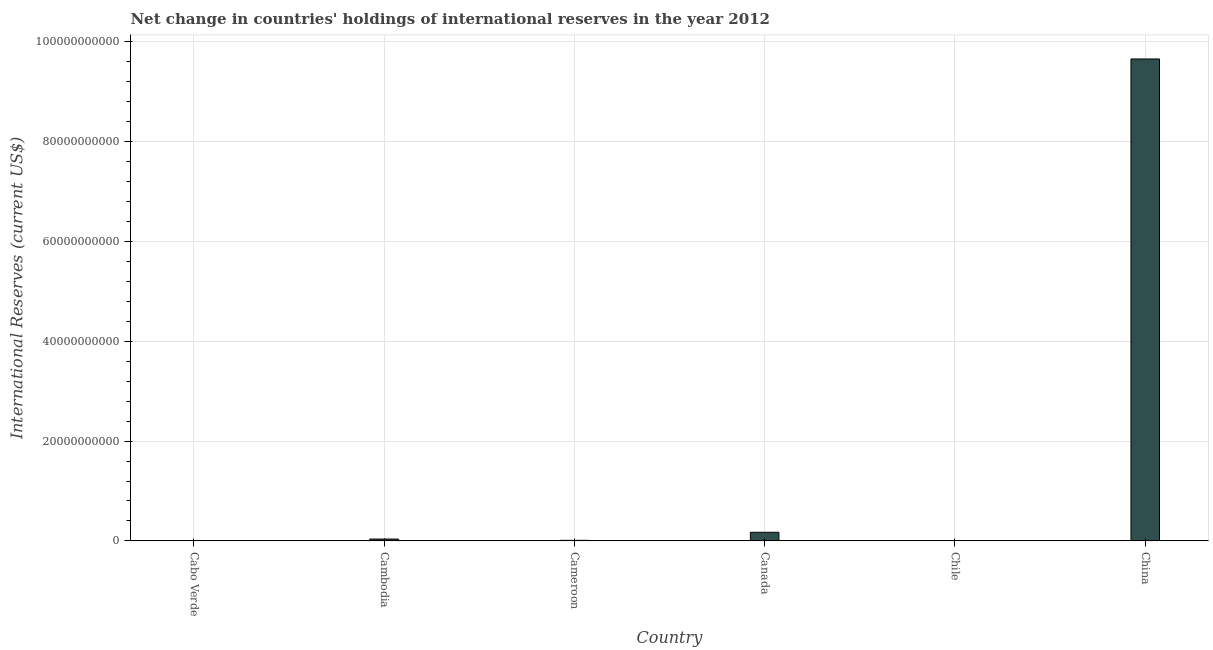What is the title of the graph?
Give a very brief answer. Net change in countries' holdings of international reserves in the year 2012. What is the label or title of the Y-axis?
Your answer should be compact. International Reserves (current US$). What is the reserves and related items in Cabo Verde?
Provide a short and direct response. 4.97e+07. Across all countries, what is the maximum reserves and related items?
Give a very brief answer. 9.66e+1. In which country was the reserves and related items maximum?
Your answer should be compact. China. What is the sum of the reserves and related items?
Offer a terse response. 9.88e+1. What is the difference between the reserves and related items in Cabo Verde and Cameroon?
Give a very brief answer. -6.90e+07. What is the average reserves and related items per country?
Ensure brevity in your answer.  1.65e+1. What is the median reserves and related items?
Keep it short and to the point. 2.47e+08. What is the ratio of the reserves and related items in Cambodia to that in Canada?
Your answer should be very brief. 0.22. Is the reserves and related items in Cambodia less than that in China?
Offer a very short reply. Yes. Is the difference between the reserves and related items in Cameroon and Canada greater than the difference between any two countries?
Provide a succinct answer. No. What is the difference between the highest and the second highest reserves and related items?
Your answer should be compact. 9.48e+1. What is the difference between the highest and the lowest reserves and related items?
Ensure brevity in your answer.  9.66e+1. How many bars are there?
Your response must be concise. 5. Are all the bars in the graph horizontal?
Keep it short and to the point. No. How many countries are there in the graph?
Offer a terse response. 6. What is the difference between two consecutive major ticks on the Y-axis?
Ensure brevity in your answer.  2.00e+1. What is the International Reserves (current US$) in Cabo Verde?
Provide a short and direct response. 4.97e+07. What is the International Reserves (current US$) of Cambodia?
Provide a short and direct response. 3.75e+08. What is the International Reserves (current US$) of Cameroon?
Provide a short and direct response. 1.19e+08. What is the International Reserves (current US$) in Canada?
Offer a very short reply. 1.73e+09. What is the International Reserves (current US$) in Chile?
Ensure brevity in your answer.  0. What is the International Reserves (current US$) in China?
Offer a terse response. 9.66e+1. What is the difference between the International Reserves (current US$) in Cabo Verde and Cambodia?
Provide a succinct answer. -3.26e+08. What is the difference between the International Reserves (current US$) in Cabo Verde and Cameroon?
Make the answer very short. -6.90e+07. What is the difference between the International Reserves (current US$) in Cabo Verde and Canada?
Make the answer very short. -1.68e+09. What is the difference between the International Reserves (current US$) in Cabo Verde and China?
Keep it short and to the point. -9.65e+1. What is the difference between the International Reserves (current US$) in Cambodia and Cameroon?
Your answer should be very brief. 2.57e+08. What is the difference between the International Reserves (current US$) in Cambodia and Canada?
Keep it short and to the point. -1.35e+09. What is the difference between the International Reserves (current US$) in Cambodia and China?
Your response must be concise. -9.62e+1. What is the difference between the International Reserves (current US$) in Cameroon and Canada?
Provide a succinct answer. -1.61e+09. What is the difference between the International Reserves (current US$) in Cameroon and China?
Keep it short and to the point. -9.64e+1. What is the difference between the International Reserves (current US$) in Canada and China?
Your answer should be very brief. -9.48e+1. What is the ratio of the International Reserves (current US$) in Cabo Verde to that in Cambodia?
Your answer should be compact. 0.13. What is the ratio of the International Reserves (current US$) in Cabo Verde to that in Cameroon?
Make the answer very short. 0.42. What is the ratio of the International Reserves (current US$) in Cabo Verde to that in Canada?
Give a very brief answer. 0.03. What is the ratio of the International Reserves (current US$) in Cambodia to that in Cameroon?
Your response must be concise. 3.16. What is the ratio of the International Reserves (current US$) in Cambodia to that in Canada?
Your response must be concise. 0.22. What is the ratio of the International Reserves (current US$) in Cambodia to that in China?
Keep it short and to the point. 0. What is the ratio of the International Reserves (current US$) in Cameroon to that in Canada?
Offer a very short reply. 0.07. What is the ratio of the International Reserves (current US$) in Canada to that in China?
Provide a succinct answer. 0.02. 